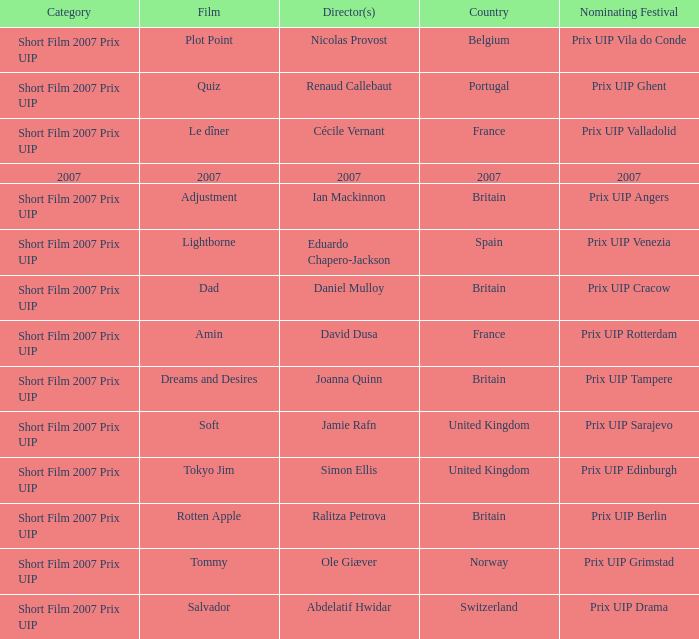Would you mind parsing the complete table? {'header': ['Category', 'Film', 'Director(s)', 'Country', 'Nominating Festival'], 'rows': [['Short Film 2007 Prix UIP', 'Plot Point', 'Nicolas Provost', 'Belgium', 'Prix UIP Vila do Conde'], ['Short Film 2007 Prix UIP', 'Quiz', 'Renaud Callebaut', 'Portugal', 'Prix UIP Ghent'], ['Short Film 2007 Prix UIP', 'Le dîner', 'Cécile Vernant', 'France', 'Prix UIP Valladolid'], ['2007', '2007', '2007', '2007', '2007'], ['Short Film 2007 Prix UIP', 'Adjustment', 'Ian Mackinnon', 'Britain', 'Prix UIP Angers'], ['Short Film 2007 Prix UIP', 'Lightborne', 'Eduardo Chapero-Jackson', 'Spain', 'Prix UIP Venezia'], ['Short Film 2007 Prix UIP', 'Dad', 'Daniel Mulloy', 'Britain', 'Prix UIP Cracow'], ['Short Film 2007 Prix UIP', 'Amin', 'David Dusa', 'France', 'Prix UIP Rotterdam'], ['Short Film 2007 Prix UIP', 'Dreams and Desires', 'Joanna Quinn', 'Britain', 'Prix UIP Tampere'], ['Short Film 2007 Prix UIP', 'Soft', 'Jamie Rafn', 'United Kingdom', 'Prix UIP Sarajevo'], ['Short Film 2007 Prix UIP', 'Tokyo Jim', 'Simon Ellis', 'United Kingdom', 'Prix UIP Edinburgh'], ['Short Film 2007 Prix UIP', 'Rotten Apple', 'Ralitza Petrova', 'Britain', 'Prix UIP Berlin'], ['Short Film 2007 Prix UIP', 'Tommy', 'Ole Giæver', 'Norway', 'Prix UIP Grimstad'], ['Short Film 2007 Prix UIP', 'Salvador', 'Abdelatif Hwidar', 'Switzerland', 'Prix UIP Drama']]} What country was the prix uip ghent nominating festival? Portugal. 